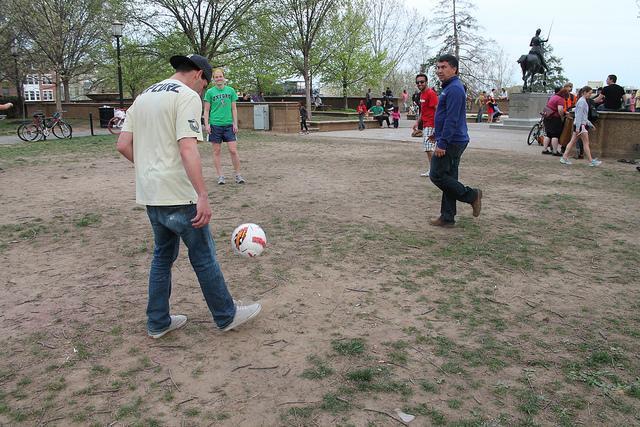How many people are wearing shorts?
Give a very brief answer. 2. How many people are there?
Give a very brief answer. 4. How many orange pillows in the image?
Give a very brief answer. 0. 